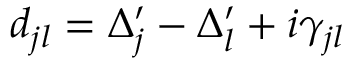Convert formula to latex. <formula><loc_0><loc_0><loc_500><loc_500>d _ { j l } = \Delta _ { j } ^ { \prime } - \Delta _ { l } ^ { \prime } + i \gamma _ { j l }</formula> 